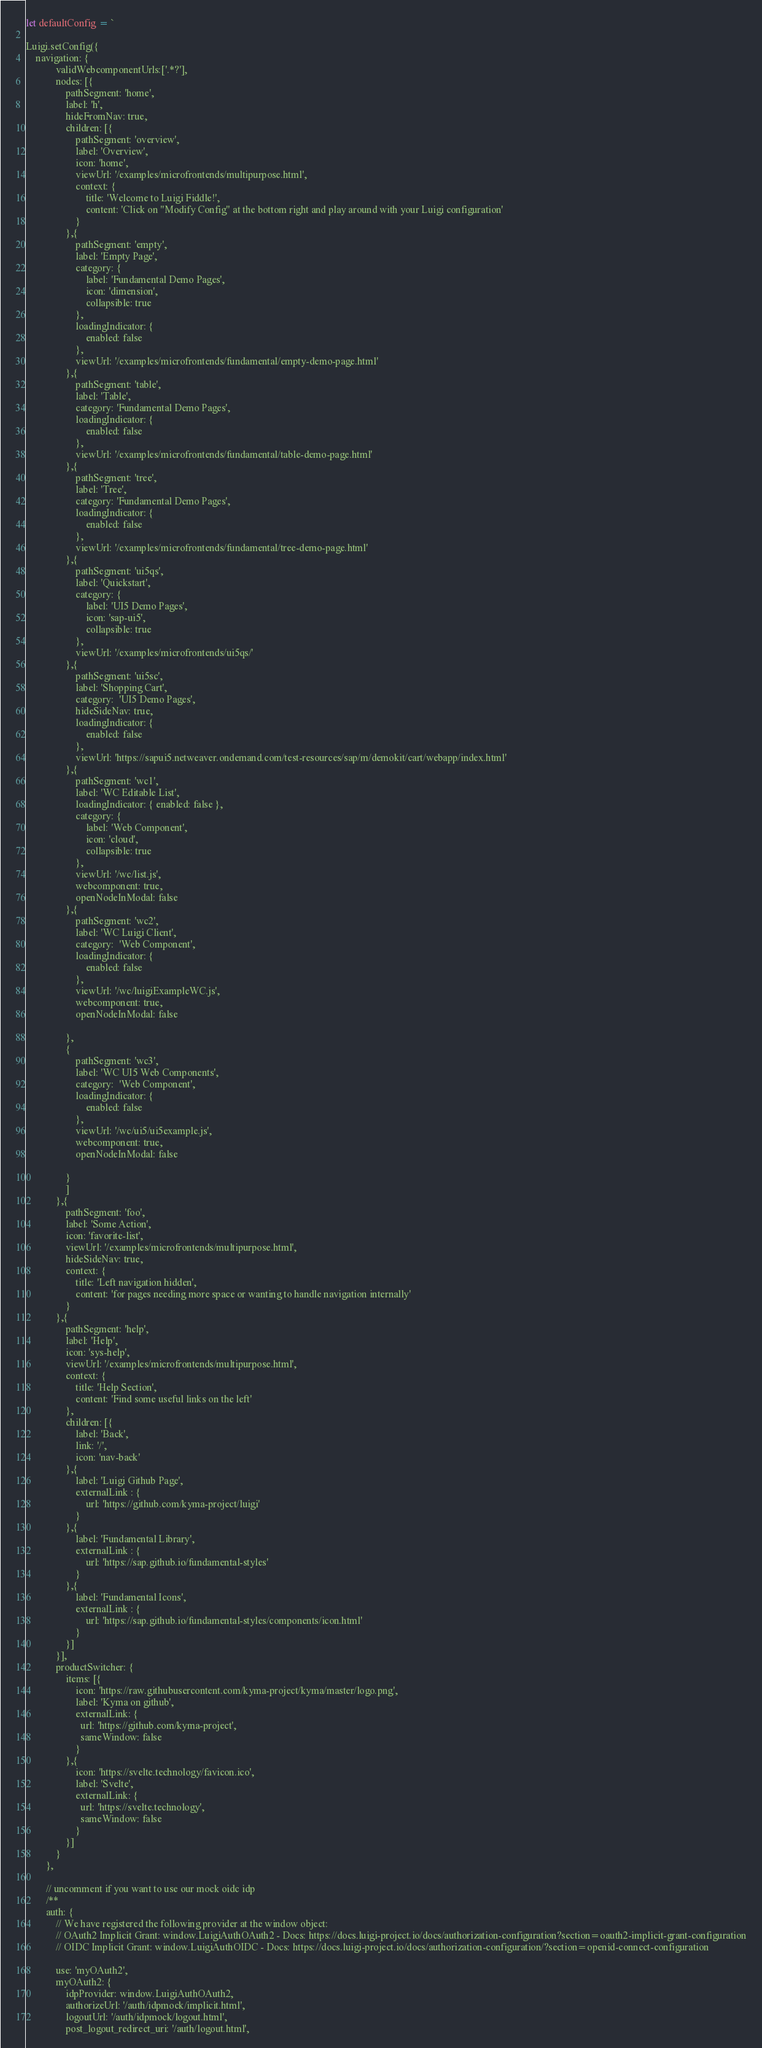<code> <loc_0><loc_0><loc_500><loc_500><_JavaScript_>let defaultConfig = `

Luigi.setConfig({
    navigation: { 
            validWebcomponentUrls:['.*?'],
            nodes: [{ 
                pathSegment: 'home', 
                label: 'h', 
                hideFromNav: true, 
                children: [{ 
                    pathSegment: 'overview', 
                    label: 'Overview', 
                    icon: 'home',
                    viewUrl: '/examples/microfrontends/multipurpose.html',
                    context: {
                        title: 'Welcome to Luigi Fiddle!',
                        content: 'Click on "Modify Config" at the bottom right and play around with your Luigi configuration'
                    }
                },{ 
                    pathSegment: 'empty', 
                    label: 'Empty Page', 
                    category: {
                        label: 'Fundamental Demo Pages',
                        icon: 'dimension',
                        collapsible: true
                    },
                    loadingIndicator: {
                        enabled: false
                    },
                    viewUrl: '/examples/microfrontends/fundamental/empty-demo-page.html'
                },{ 
                    pathSegment: 'table', 
                    label: 'Table', 
                    category: 'Fundamental Demo Pages',
                    loadingIndicator: {
                        enabled: false
                    },
                    viewUrl: '/examples/microfrontends/fundamental/table-demo-page.html'
                },{ 
                    pathSegment: 'tree', 
                    label: 'Tree', 
                    category: 'Fundamental Demo Pages',
                    loadingIndicator: {
                        enabled: false
                    },
                    viewUrl: '/examples/microfrontends/fundamental/tree-demo-page.html'
                },{ 
                    pathSegment: 'ui5qs', 
                    label: 'Quickstart', 
                    category: {
                        label: 'UI5 Demo Pages',
                        icon: 'sap-ui5',
                        collapsible: true
                    },
                    viewUrl: '/examples/microfrontends/ui5qs/'
                },{ 
                    pathSegment: 'ui5sc', 
                    label: 'Shopping Cart', 
                    category:  'UI5 Demo Pages',
                    hideSideNav: true,
                    loadingIndicator: {
                        enabled: false
                    },
                    viewUrl: 'https://sapui5.netweaver.ondemand.com/test-resources/sap/m/demokit/cart/webapp/index.html'
                },{ 
                    pathSegment: 'wc1', 
                    label: 'WC Editable List', 
                    loadingIndicator: { enabled: false },
                    category: {
                        label: 'Web Component',
                        icon: 'cloud',
                        collapsible: true
                    },
                    viewUrl: '/wc/list.js',
                    webcomponent: true,
                    openNodeInModal: false
                },{ 
                    pathSegment: 'wc2', 
                    label: 'WC Luigi Client', 
                    category:  'Web Component',
                    loadingIndicator: {
                        enabled: false
                    },
                    viewUrl: '/wc/luigiExampleWC.js',
                    webcomponent: true,
                    openNodeInModal: false
               
                },
                { 
                    pathSegment: 'wc3', 
                    label: 'WC UI5 Web Components', 
                    category:  'Web Component',
                    loadingIndicator: {
                        enabled: false
                    },
                    viewUrl: '/wc/ui5/ui5example.js',
                    webcomponent: true,
                    openNodeInModal: false
               
                }
                ] 
            },{ 
                pathSegment: 'foo', 
                label: 'Some Action',
                icon: 'favorite-list',
                viewUrl: '/examples/microfrontends/multipurpose.html',
                hideSideNav: true,
                context: {
                    title: 'Left navigation hidden',
                    content: 'for pages needing more space or wanting to handle navigation internally'  
                }
            },{ 
                pathSegment: 'help', 
                label: 'Help',
                icon: 'sys-help',
                viewUrl: '/examples/microfrontends/multipurpose.html',
                context: {
                    title: 'Help Section',
                    content: 'Find some useful links on the left'  
                },
                children: [{
                    label: 'Back',
                    link: '/',
                    icon: 'nav-back'
                },{
                    label: 'Luigi Github Page',
                    externalLink : { 
                        url: 'https://github.com/kyma-project/luigi'
                    }
                },{
                    label: 'Fundamental Library',
                    externalLink : { 
                        url: 'https://sap.github.io/fundamental-styles'
                    }
                },{
                    label: 'Fundamental Icons',
                    externalLink : { 
                        url: 'https://sap.github.io/fundamental-styles/components/icon.html'
                    }
                }]
            }],
            productSwitcher: {
                items: [{
                    icon: 'https://raw.githubusercontent.com/kyma-project/kyma/master/logo.png',
                    label: 'Kyma on github',
                    externalLink: {
                      url: 'https://github.com/kyma-project',
                      sameWindow: false
                    }
                },{
                    icon: 'https://svelte.technology/favicon.ico',
                    label: 'Svelte',
                    externalLink: {
                      url: 'https://svelte.technology',
                      sameWindow: false
                    }
                }]
            } 
        }, 
        
        // uncomment if you want to use our mock oidc idp
        /**
        auth: {
            // We have registered the following provider at the window object:
            // OAuth2 Implicit Grant: window.LuigiAuthOAuth2 - Docs: https://docs.luigi-project.io/docs/authorization-configuration?section=oauth2-implicit-grant-configuration
            // OIDC Implicit Grant: window.LuigiAuthOIDC - Docs: https://docs.luigi-project.io/docs/authorization-configuration/?section=openid-connect-configuration
 
            use: 'myOAuth2',
            myOAuth2: {
                idpProvider: window.LuigiAuthOAuth2,
                authorizeUrl: '/auth/idpmock/implicit.html',
                logoutUrl: '/auth/idpmock/logout.html',
                post_logout_redirect_uri: '/auth/logout.html',</code> 